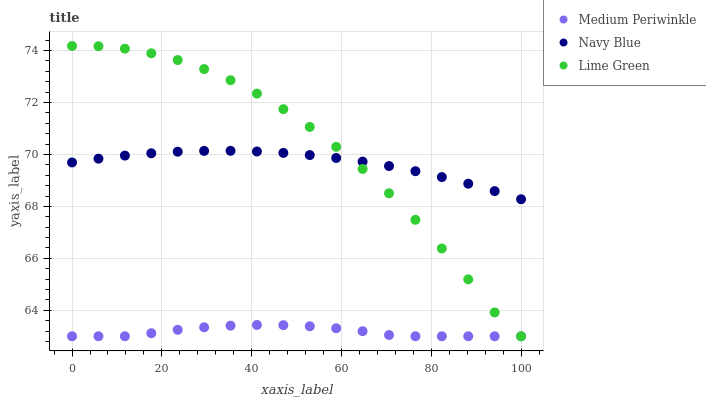Does Medium Periwinkle have the minimum area under the curve?
Answer yes or no. Yes. Does Lime Green have the maximum area under the curve?
Answer yes or no. Yes. Does Lime Green have the minimum area under the curve?
Answer yes or no. No. Does Medium Periwinkle have the maximum area under the curve?
Answer yes or no. No. Is Navy Blue the smoothest?
Answer yes or no. Yes. Is Lime Green the roughest?
Answer yes or no. Yes. Is Medium Periwinkle the smoothest?
Answer yes or no. No. Is Medium Periwinkle the roughest?
Answer yes or no. No. Does Medium Periwinkle have the lowest value?
Answer yes or no. Yes. Does Lime Green have the highest value?
Answer yes or no. Yes. Does Medium Periwinkle have the highest value?
Answer yes or no. No. Is Medium Periwinkle less than Navy Blue?
Answer yes or no. Yes. Is Navy Blue greater than Medium Periwinkle?
Answer yes or no. Yes. Does Lime Green intersect Navy Blue?
Answer yes or no. Yes. Is Lime Green less than Navy Blue?
Answer yes or no. No. Is Lime Green greater than Navy Blue?
Answer yes or no. No. Does Medium Periwinkle intersect Navy Blue?
Answer yes or no. No. 